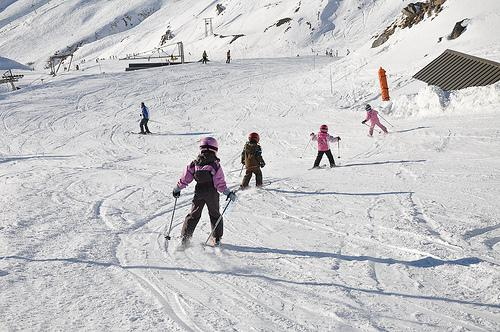Question: what are these people doing?
Choices:
A. Surfing.
B. Biking.
C. Skiing.
D. Hiking.
Answer with the letter. Answer: C Question: where is this picture taken?
Choices:
A. In the snow.
B. In the sand.
C. In the water.
D. In the carnival.
Answer with the letter. Answer: A Question: what are they skiing on?
Choices:
A. The water.
B. The mountain.
C. The mud.
D. The snow.
Answer with the letter. Answer: D Question: what are the dark images reflecting off the snow?
Choices:
A. Dogs.
B. People.
C. Buildings.
D. Shadows.
Answer with the letter. Answer: D Question: where are the rocks?
Choices:
A. In the right side of the picture.
B. On the hillside.
C. Next to the stream.
D. On the road.
Answer with the letter. Answer: A Question: how many of the people are wearing bright yellow pants?
Choices:
A. One.
B. Two.
C. None.
D. Three.
Answer with the letter. Answer: C Question: where is the helicopter?
Choices:
A. Above the building.
B. Below the clouds.
C. Over the town.
D. There is no helicopter.
Answer with the letter. Answer: D 